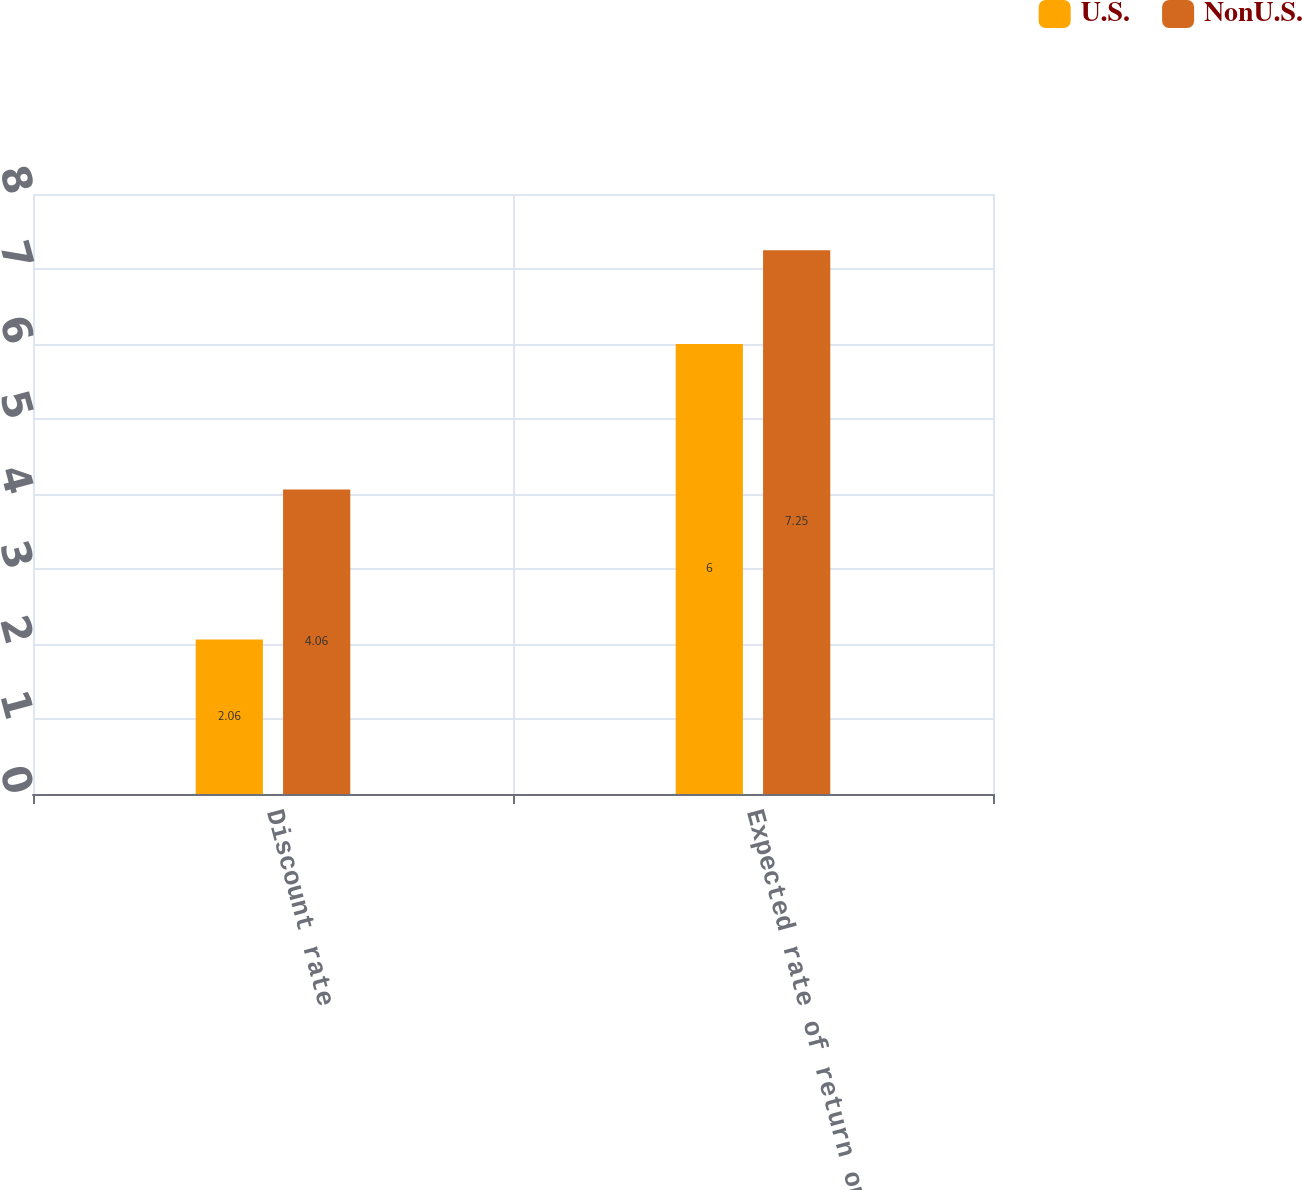<chart> <loc_0><loc_0><loc_500><loc_500><stacked_bar_chart><ecel><fcel>Discount rate<fcel>Expected rate of return on<nl><fcel>U.S.<fcel>2.06<fcel>6<nl><fcel>NonU.S.<fcel>4.06<fcel>7.25<nl></chart> 